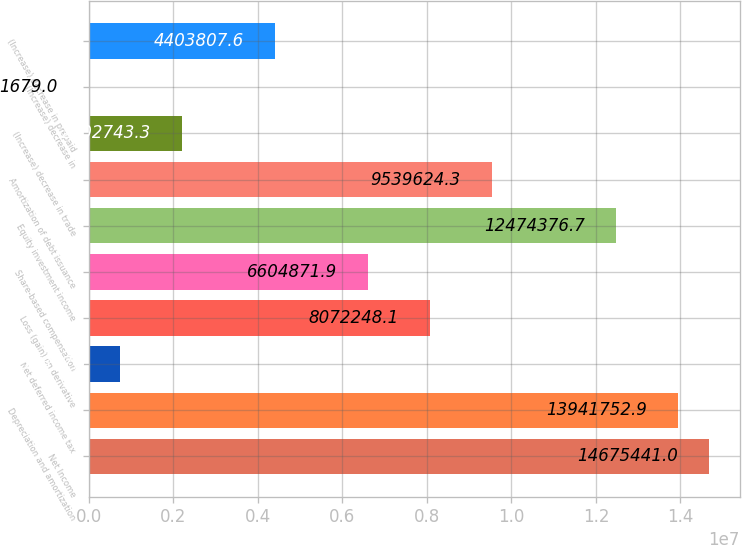<chart> <loc_0><loc_0><loc_500><loc_500><bar_chart><fcel>Net Income<fcel>Depreciation and amortization<fcel>Net deferred income tax<fcel>Loss (gain) on derivative<fcel>Share-based compensation<fcel>Equity investment income<fcel>Amortization of debt issuance<fcel>(Increase) decrease in trade<fcel>(Increase) decrease in<fcel>(Increase) decrease in prepaid<nl><fcel>1.46754e+07<fcel>1.39418e+07<fcel>735367<fcel>8.07225e+06<fcel>6.60487e+06<fcel>1.24744e+07<fcel>9.53962e+06<fcel>2.20274e+06<fcel>1679<fcel>4.40381e+06<nl></chart> 